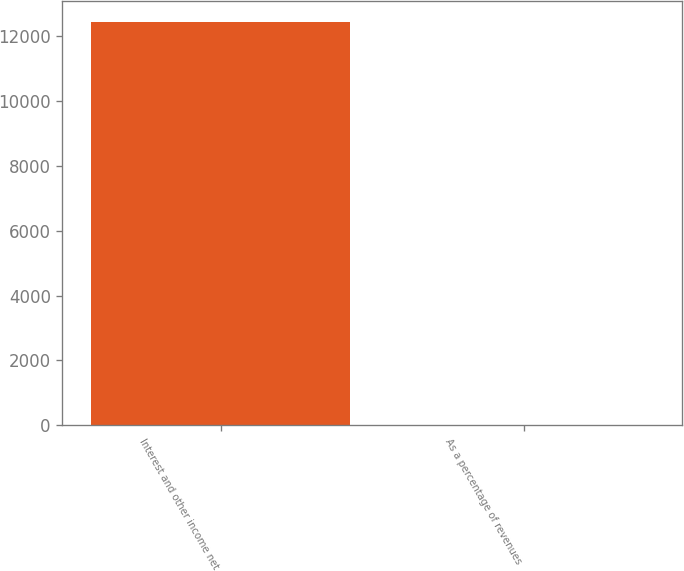<chart> <loc_0><loc_0><loc_500><loc_500><bar_chart><fcel>Interest and other income net<fcel>As a percentage of revenues<nl><fcel>12452<fcel>0.9<nl></chart> 